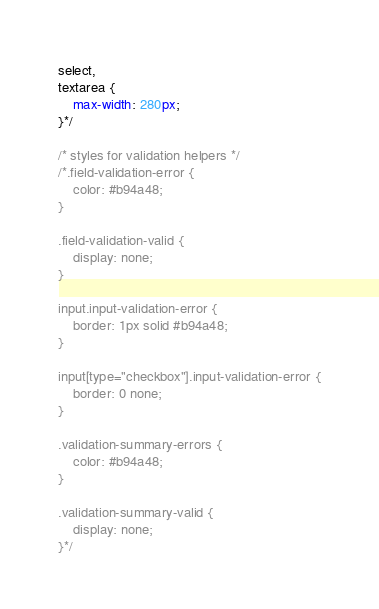Convert code to text. <code><loc_0><loc_0><loc_500><loc_500><_CSS_>select,
textarea {
    max-width: 280px;
}*/

/* styles for validation helpers */
/*.field-validation-error {
    color: #b94a48;
}

.field-validation-valid {
    display: none;
}

input.input-validation-error {
    border: 1px solid #b94a48;
}

input[type="checkbox"].input-validation-error {
    border: 0 none;
}

.validation-summary-errors {
    color: #b94a48;
}

.validation-summary-valid {
    display: none;
}*/</code> 